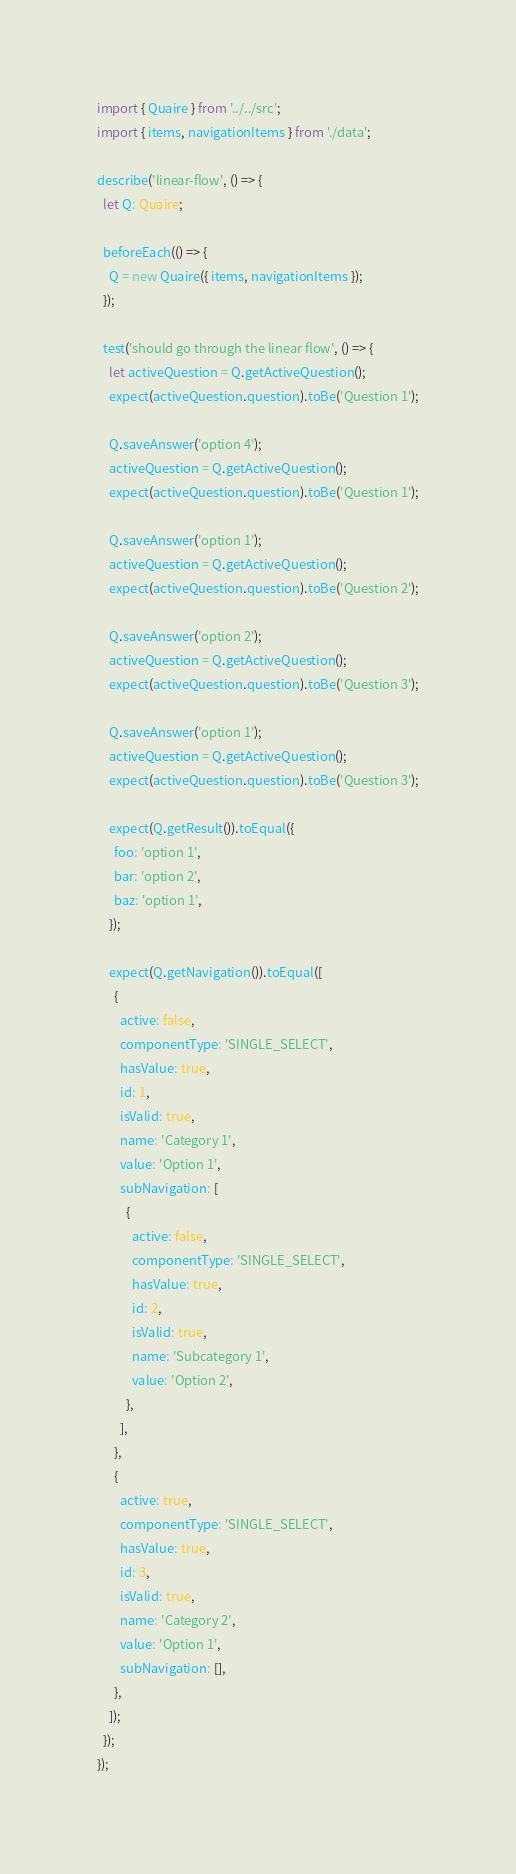<code> <loc_0><loc_0><loc_500><loc_500><_TypeScript_>import { Quaire } from '../../src';
import { items, navigationItems } from './data';

describe('linear-flow', () => {
  let Q: Quaire;

  beforeEach(() => {
    Q = new Quaire({ items, navigationItems });
  });

  test('should go through the linear flow', () => {
    let activeQuestion = Q.getActiveQuestion();
    expect(activeQuestion.question).toBe('Question 1');

    Q.saveAnswer('option 4');
    activeQuestion = Q.getActiveQuestion();
    expect(activeQuestion.question).toBe('Question 1');

    Q.saveAnswer('option 1');
    activeQuestion = Q.getActiveQuestion();
    expect(activeQuestion.question).toBe('Question 2');

    Q.saveAnswer('option 2');
    activeQuestion = Q.getActiveQuestion();
    expect(activeQuestion.question).toBe('Question 3');

    Q.saveAnswer('option 1');
    activeQuestion = Q.getActiveQuestion();
    expect(activeQuestion.question).toBe('Question 3');

    expect(Q.getResult()).toEqual({
      foo: 'option 1',
      bar: 'option 2',
      baz: 'option 1',
    });

    expect(Q.getNavigation()).toEqual([
      {
        active: false,
        componentType: 'SINGLE_SELECT',
        hasValue: true,
        id: 1,
        isValid: true,
        name: 'Category 1',
        value: 'Option 1',
        subNavigation: [
          {
            active: false,
            componentType: 'SINGLE_SELECT',
            hasValue: true,
            id: 2,
            isValid: true,
            name: 'Subcategory 1',
            value: 'Option 2',
          },
        ],
      },
      {
        active: true,
        componentType: 'SINGLE_SELECT',
        hasValue: true,
        id: 3,
        isValid: true,
        name: 'Category 2',
        value: 'Option 1',
        subNavigation: [],
      },
    ]);
  });
});
</code> 